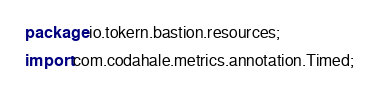Convert code to text. <code><loc_0><loc_0><loc_500><loc_500><_Java_>package io.tokern.bastion.resources;

import com.codahale.metrics.annotation.Timed;</code> 